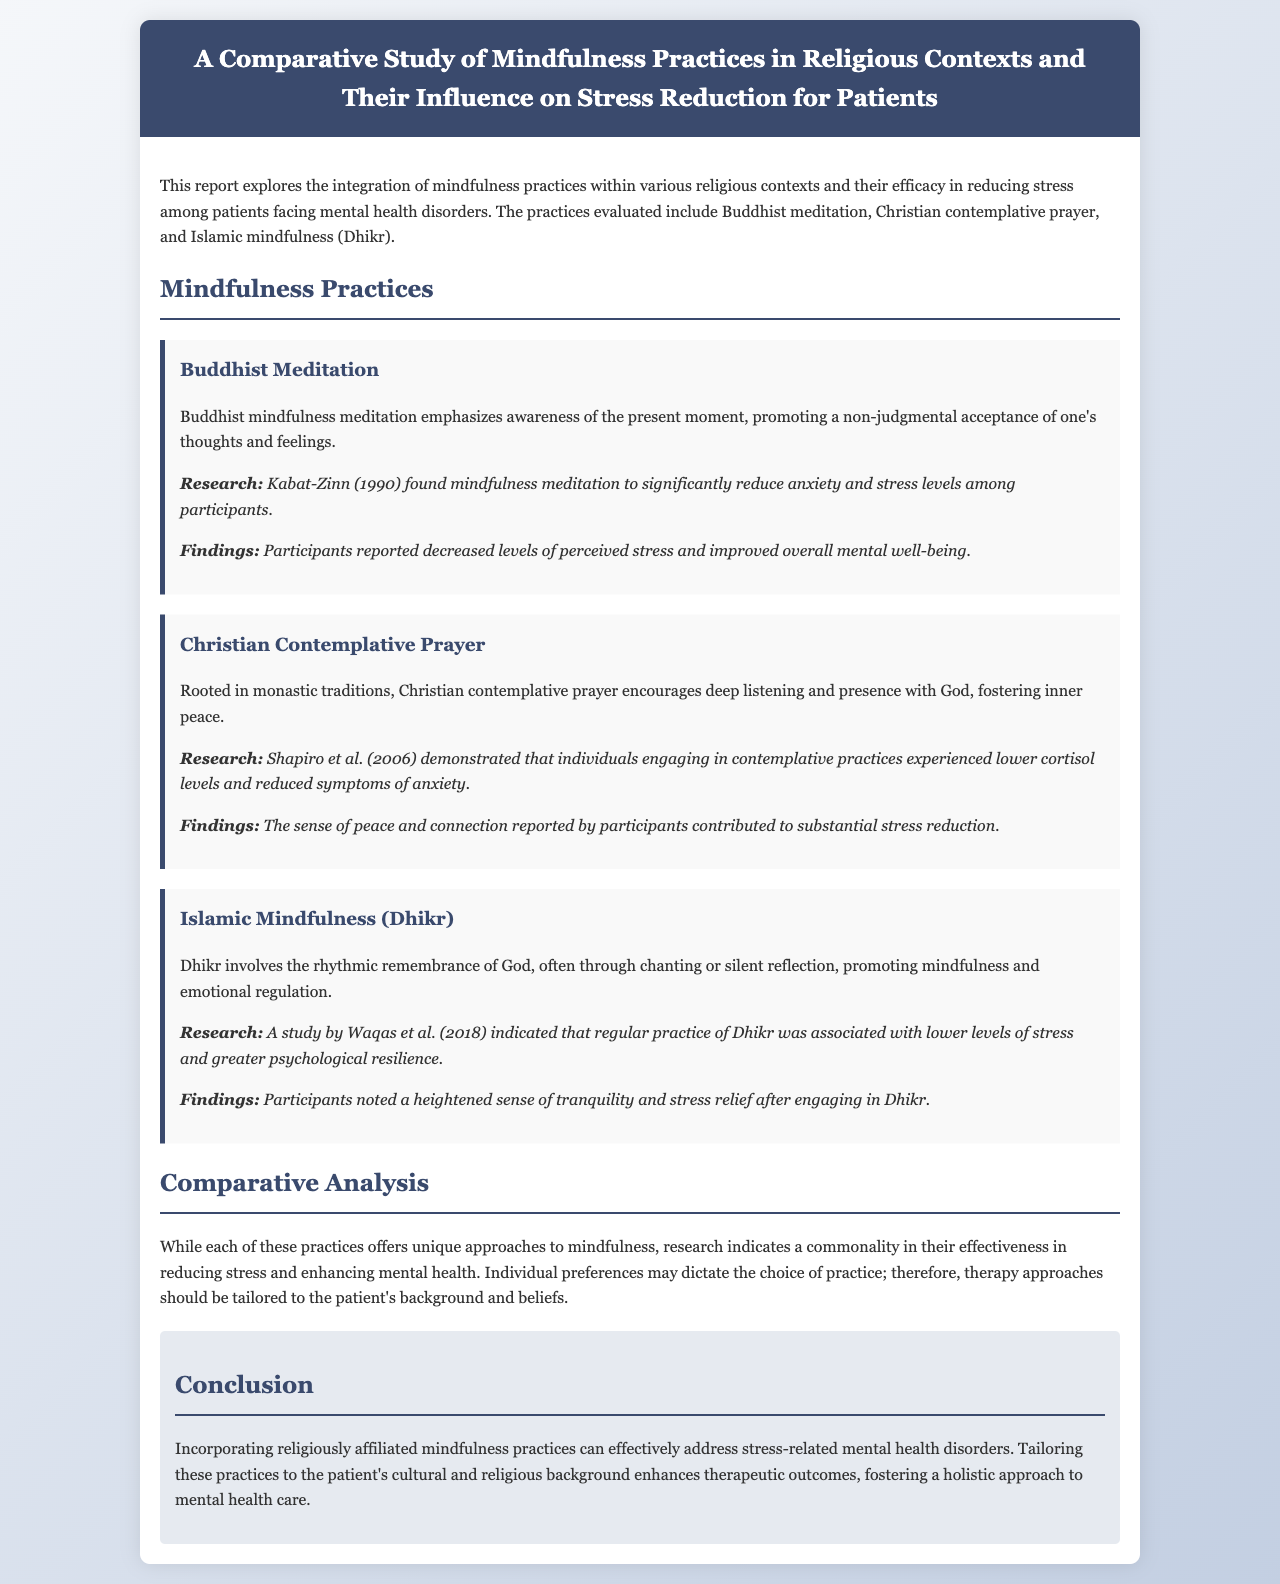What mindfulness practice is mentioned for Buddhism? The mindfulness practice mentioned for Buddhism is "Buddhist meditation."
Answer: Buddhist meditation What is the primary focus of Christian contemplative prayer? The primary focus of Christian contemplative prayer is "deep listening and presence with God."
Answer: deep listening and presence with God Who conducted research on the effects of mindfulness meditation? The research on the effects of mindfulness meditation was conducted by "Kabat-Zinn."
Answer: Kabat-Zinn What did Waqas et al. find regarding the practice of Dhikr? Waqas et al. found that regular practice of Dhikr was associated with "lower levels of stress."
Answer: lower levels of stress How do the practices relate in terms of their effectiveness in reducing stress? The practices are noted to have a "commonality in their effectiveness in reducing stress."
Answer: commonality in their effectiveness in reducing stress What are the suggested therapy approaches based on practice preference? Therapy approaches should be "tailored to the patient's background and beliefs."
Answer: tailored to the patient's background and beliefs What is the conclusion regarding religiously affiliated mindfulness practices? The conclusion states that these practices can "effectively address stress-related mental health disorders."
Answer: effectively address stress-related mental health disorders Which study demonstrated lower cortisol levels through contemplative practices? The study that demonstrated lower cortisol levels is by "Shapiro et al."
Answer: Shapiro et al 